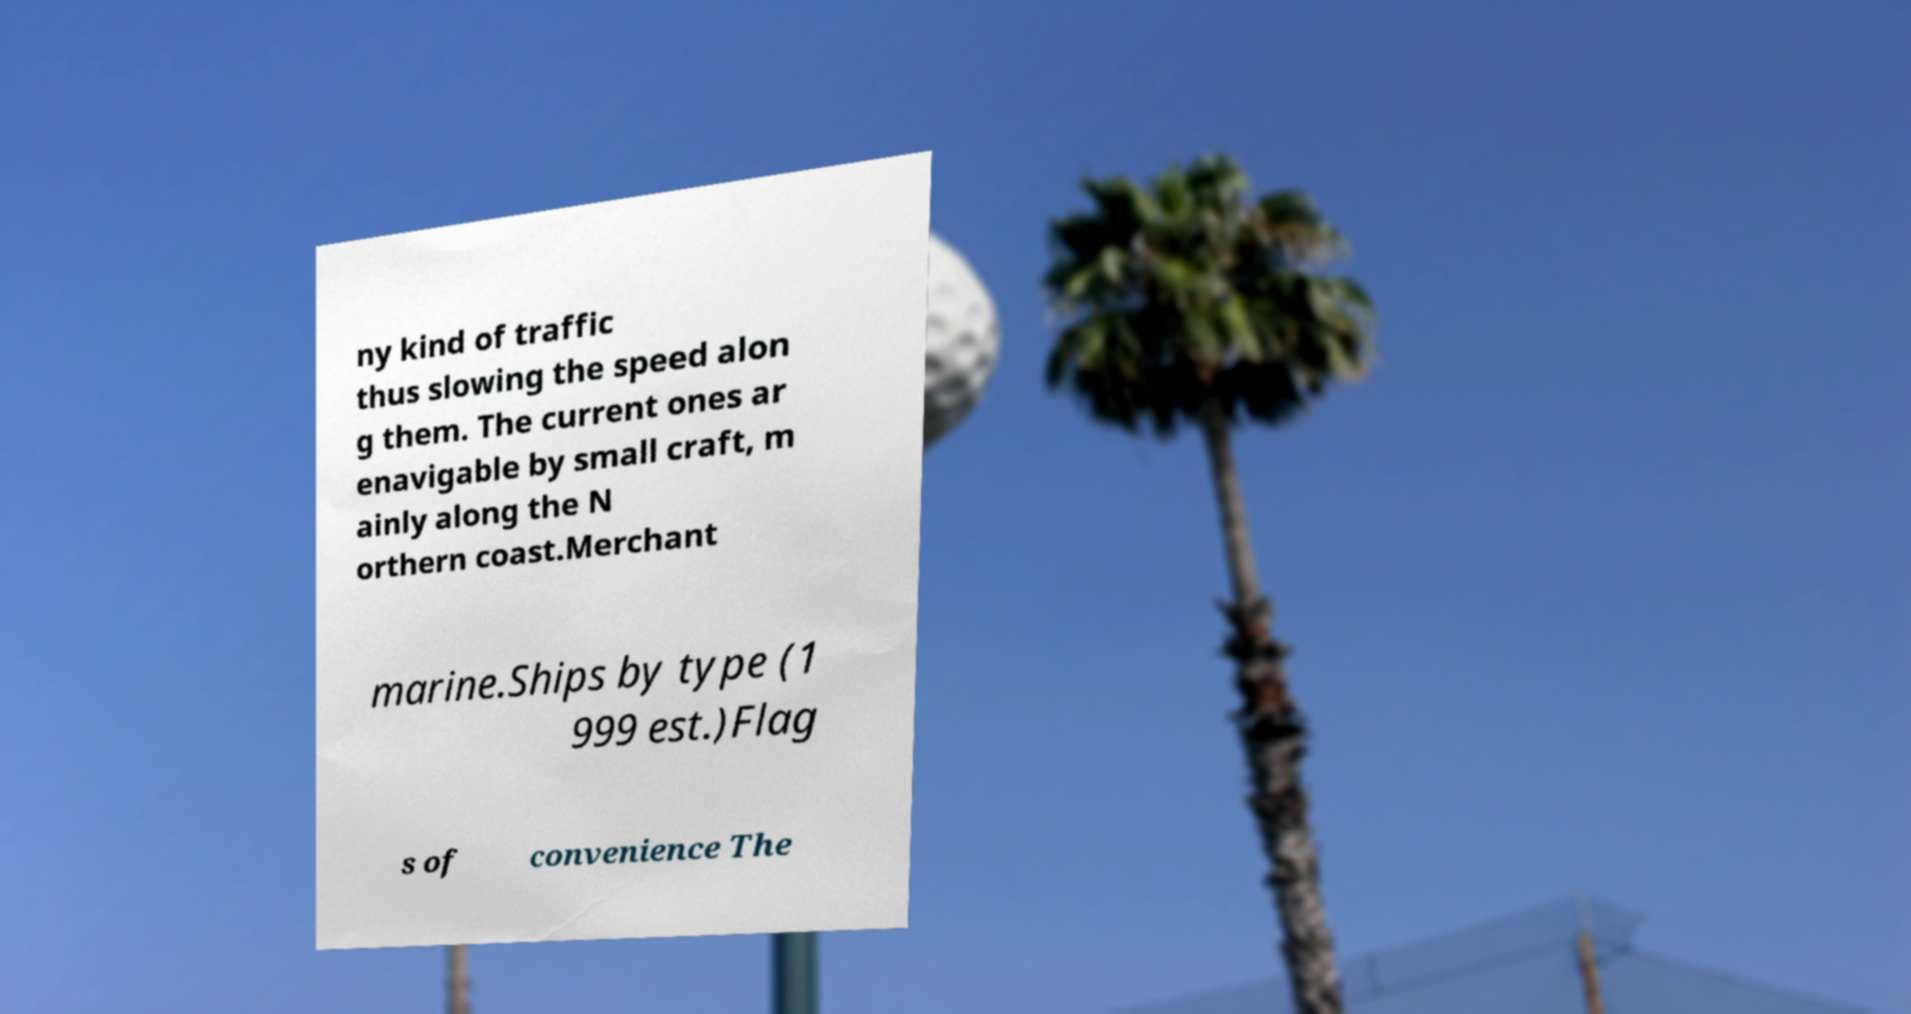Can you read and provide the text displayed in the image?This photo seems to have some interesting text. Can you extract and type it out for me? ny kind of traffic thus slowing the speed alon g them. The current ones ar enavigable by small craft, m ainly along the N orthern coast.Merchant marine.Ships by type (1 999 est.)Flag s of convenience The 